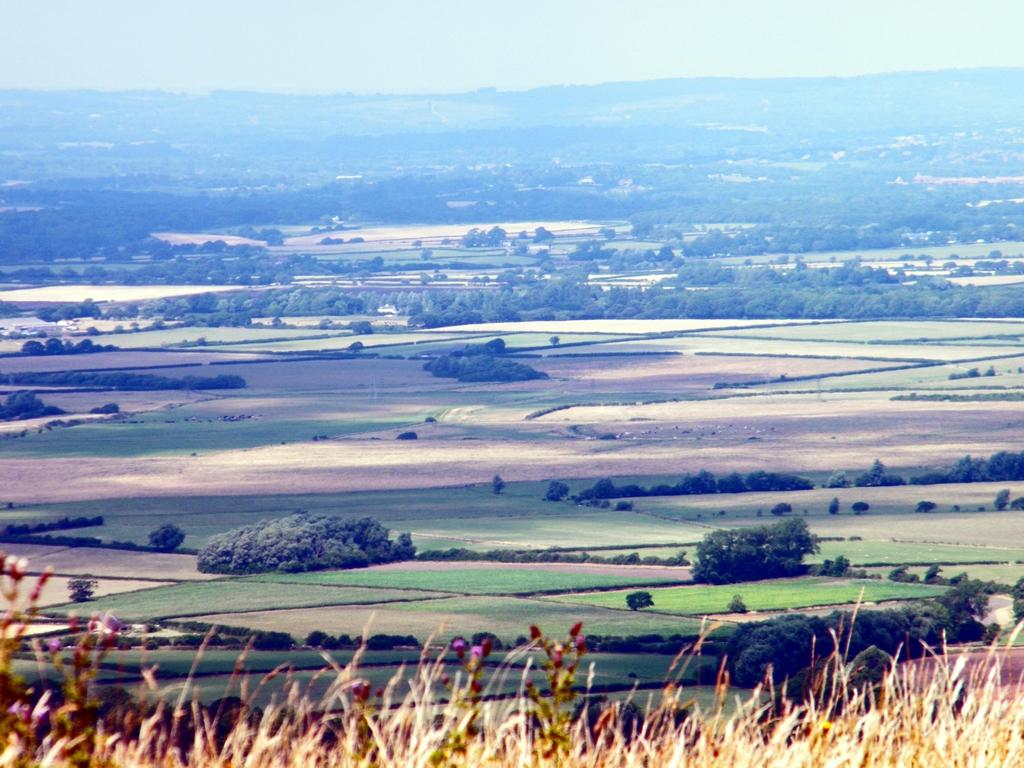What types of vegetation are present at the bottom of the image? There are plants at the bottom of the image. What can be seen in the distance in the image? There are trees visible in the background of the image. Where is the cobweb located in the image? There is no cobweb present in the image. What stage of development can be observed in the doll in the image? There is no doll present in the image, so it is not possible to determine its stage of development. 